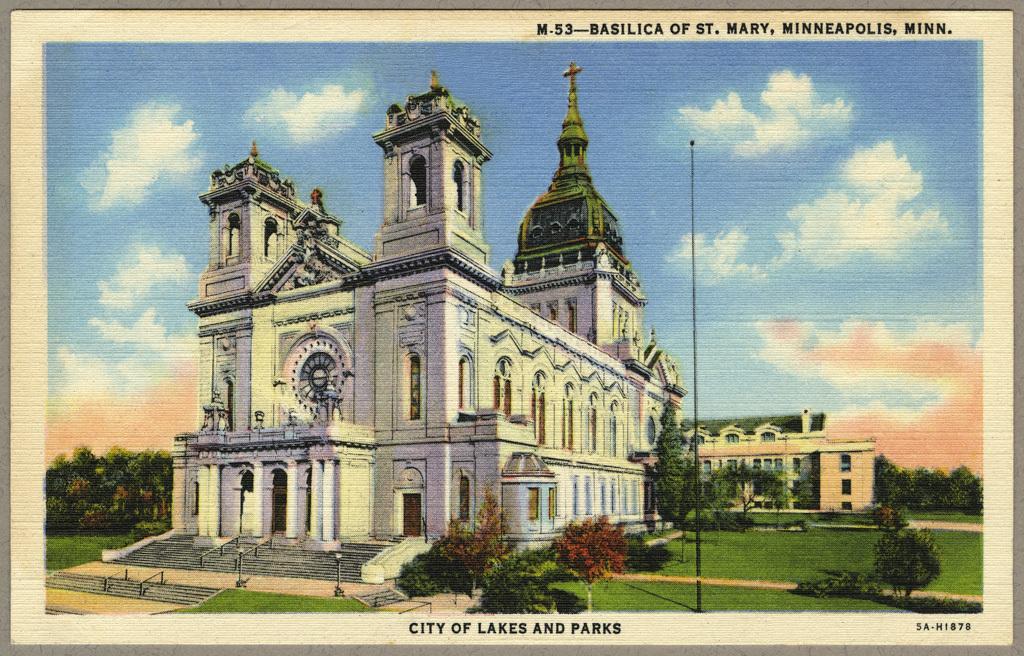Can you describe this image briefly? It is an edited image,there is a big church and behind the church there is another building,around the church there is a beautiful greenery,in the background there is a sky and clouds. 